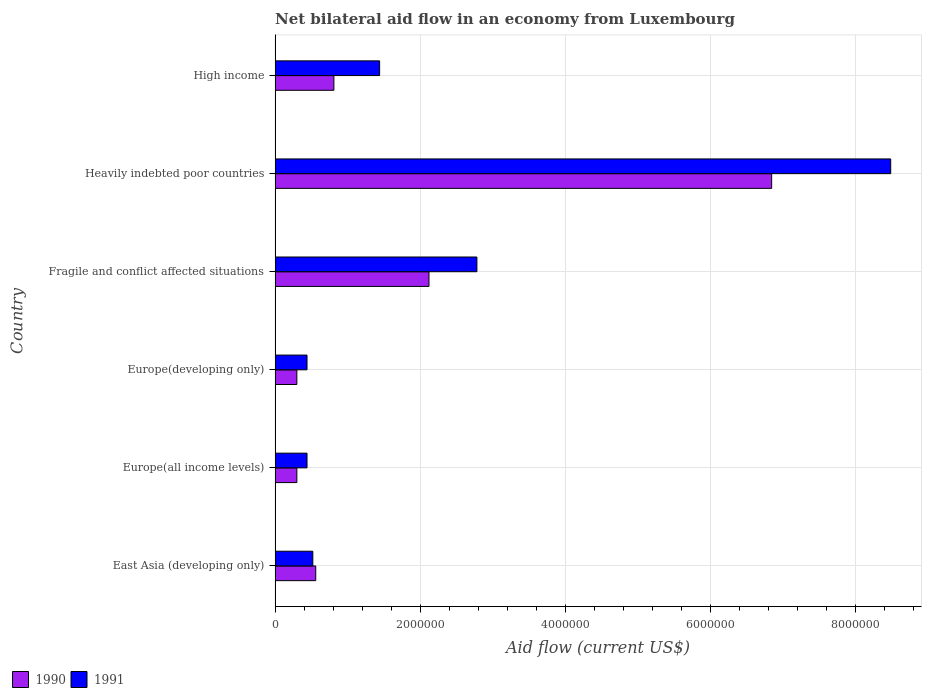How many groups of bars are there?
Give a very brief answer. 6. How many bars are there on the 2nd tick from the top?
Make the answer very short. 2. What is the label of the 3rd group of bars from the top?
Make the answer very short. Fragile and conflict affected situations. What is the net bilateral aid flow in 1990 in East Asia (developing only)?
Your response must be concise. 5.60e+05. Across all countries, what is the maximum net bilateral aid flow in 1990?
Make the answer very short. 6.84e+06. In which country was the net bilateral aid flow in 1991 maximum?
Provide a succinct answer. Heavily indebted poor countries. In which country was the net bilateral aid flow in 1991 minimum?
Your answer should be compact. Europe(all income levels). What is the total net bilateral aid flow in 1991 in the graph?
Your answer should be very brief. 1.41e+07. What is the difference between the net bilateral aid flow in 1990 in East Asia (developing only) and that in High income?
Offer a very short reply. -2.50e+05. What is the difference between the net bilateral aid flow in 1991 in Europe(all income levels) and the net bilateral aid flow in 1990 in High income?
Make the answer very short. -3.70e+05. What is the average net bilateral aid flow in 1991 per country?
Your answer should be compact. 2.35e+06. What is the difference between the net bilateral aid flow in 1990 and net bilateral aid flow in 1991 in Fragile and conflict affected situations?
Provide a succinct answer. -6.60e+05. What is the ratio of the net bilateral aid flow in 1991 in Fragile and conflict affected situations to that in High income?
Your response must be concise. 1.93. Is the difference between the net bilateral aid flow in 1990 in East Asia (developing only) and Europe(developing only) greater than the difference between the net bilateral aid flow in 1991 in East Asia (developing only) and Europe(developing only)?
Keep it short and to the point. Yes. What is the difference between the highest and the second highest net bilateral aid flow in 1990?
Provide a succinct answer. 4.72e+06. What is the difference between the highest and the lowest net bilateral aid flow in 1991?
Provide a succinct answer. 8.04e+06. In how many countries, is the net bilateral aid flow in 1990 greater than the average net bilateral aid flow in 1990 taken over all countries?
Your answer should be very brief. 2. What does the 1st bar from the top in Fragile and conflict affected situations represents?
Provide a short and direct response. 1991. How many countries are there in the graph?
Provide a succinct answer. 6. Are the values on the major ticks of X-axis written in scientific E-notation?
Keep it short and to the point. No. How many legend labels are there?
Offer a terse response. 2. How are the legend labels stacked?
Give a very brief answer. Horizontal. What is the title of the graph?
Ensure brevity in your answer.  Net bilateral aid flow in an economy from Luxembourg. What is the Aid flow (current US$) in 1990 in East Asia (developing only)?
Provide a succinct answer. 5.60e+05. What is the Aid flow (current US$) of 1991 in East Asia (developing only)?
Offer a terse response. 5.20e+05. What is the Aid flow (current US$) in 1991 in Europe(all income levels)?
Ensure brevity in your answer.  4.40e+05. What is the Aid flow (current US$) of 1991 in Europe(developing only)?
Your answer should be very brief. 4.40e+05. What is the Aid flow (current US$) of 1990 in Fragile and conflict affected situations?
Your answer should be compact. 2.12e+06. What is the Aid flow (current US$) in 1991 in Fragile and conflict affected situations?
Your answer should be compact. 2.78e+06. What is the Aid flow (current US$) in 1990 in Heavily indebted poor countries?
Make the answer very short. 6.84e+06. What is the Aid flow (current US$) in 1991 in Heavily indebted poor countries?
Your answer should be very brief. 8.48e+06. What is the Aid flow (current US$) of 1990 in High income?
Offer a terse response. 8.10e+05. What is the Aid flow (current US$) of 1991 in High income?
Your answer should be very brief. 1.44e+06. Across all countries, what is the maximum Aid flow (current US$) of 1990?
Your answer should be very brief. 6.84e+06. Across all countries, what is the maximum Aid flow (current US$) of 1991?
Ensure brevity in your answer.  8.48e+06. Across all countries, what is the minimum Aid flow (current US$) in 1990?
Offer a terse response. 3.00e+05. Across all countries, what is the minimum Aid flow (current US$) of 1991?
Your response must be concise. 4.40e+05. What is the total Aid flow (current US$) in 1990 in the graph?
Your response must be concise. 1.09e+07. What is the total Aid flow (current US$) in 1991 in the graph?
Your answer should be very brief. 1.41e+07. What is the difference between the Aid flow (current US$) of 1990 in East Asia (developing only) and that in Europe(developing only)?
Your answer should be very brief. 2.60e+05. What is the difference between the Aid flow (current US$) in 1991 in East Asia (developing only) and that in Europe(developing only)?
Provide a succinct answer. 8.00e+04. What is the difference between the Aid flow (current US$) of 1990 in East Asia (developing only) and that in Fragile and conflict affected situations?
Give a very brief answer. -1.56e+06. What is the difference between the Aid flow (current US$) in 1991 in East Asia (developing only) and that in Fragile and conflict affected situations?
Keep it short and to the point. -2.26e+06. What is the difference between the Aid flow (current US$) of 1990 in East Asia (developing only) and that in Heavily indebted poor countries?
Offer a very short reply. -6.28e+06. What is the difference between the Aid flow (current US$) of 1991 in East Asia (developing only) and that in Heavily indebted poor countries?
Ensure brevity in your answer.  -7.96e+06. What is the difference between the Aid flow (current US$) of 1990 in East Asia (developing only) and that in High income?
Make the answer very short. -2.50e+05. What is the difference between the Aid flow (current US$) in 1991 in East Asia (developing only) and that in High income?
Offer a terse response. -9.20e+05. What is the difference between the Aid flow (current US$) in 1990 in Europe(all income levels) and that in Europe(developing only)?
Your answer should be compact. 0. What is the difference between the Aid flow (current US$) of 1991 in Europe(all income levels) and that in Europe(developing only)?
Ensure brevity in your answer.  0. What is the difference between the Aid flow (current US$) of 1990 in Europe(all income levels) and that in Fragile and conflict affected situations?
Provide a succinct answer. -1.82e+06. What is the difference between the Aid flow (current US$) in 1991 in Europe(all income levels) and that in Fragile and conflict affected situations?
Make the answer very short. -2.34e+06. What is the difference between the Aid flow (current US$) in 1990 in Europe(all income levels) and that in Heavily indebted poor countries?
Make the answer very short. -6.54e+06. What is the difference between the Aid flow (current US$) in 1991 in Europe(all income levels) and that in Heavily indebted poor countries?
Your answer should be very brief. -8.04e+06. What is the difference between the Aid flow (current US$) in 1990 in Europe(all income levels) and that in High income?
Your answer should be compact. -5.10e+05. What is the difference between the Aid flow (current US$) in 1990 in Europe(developing only) and that in Fragile and conflict affected situations?
Make the answer very short. -1.82e+06. What is the difference between the Aid flow (current US$) of 1991 in Europe(developing only) and that in Fragile and conflict affected situations?
Provide a succinct answer. -2.34e+06. What is the difference between the Aid flow (current US$) of 1990 in Europe(developing only) and that in Heavily indebted poor countries?
Provide a succinct answer. -6.54e+06. What is the difference between the Aid flow (current US$) of 1991 in Europe(developing only) and that in Heavily indebted poor countries?
Your response must be concise. -8.04e+06. What is the difference between the Aid flow (current US$) in 1990 in Europe(developing only) and that in High income?
Provide a short and direct response. -5.10e+05. What is the difference between the Aid flow (current US$) in 1990 in Fragile and conflict affected situations and that in Heavily indebted poor countries?
Keep it short and to the point. -4.72e+06. What is the difference between the Aid flow (current US$) in 1991 in Fragile and conflict affected situations and that in Heavily indebted poor countries?
Offer a terse response. -5.70e+06. What is the difference between the Aid flow (current US$) in 1990 in Fragile and conflict affected situations and that in High income?
Your answer should be very brief. 1.31e+06. What is the difference between the Aid flow (current US$) of 1991 in Fragile and conflict affected situations and that in High income?
Make the answer very short. 1.34e+06. What is the difference between the Aid flow (current US$) in 1990 in Heavily indebted poor countries and that in High income?
Make the answer very short. 6.03e+06. What is the difference between the Aid flow (current US$) in 1991 in Heavily indebted poor countries and that in High income?
Provide a short and direct response. 7.04e+06. What is the difference between the Aid flow (current US$) of 1990 in East Asia (developing only) and the Aid flow (current US$) of 1991 in Europe(all income levels)?
Give a very brief answer. 1.20e+05. What is the difference between the Aid flow (current US$) of 1990 in East Asia (developing only) and the Aid flow (current US$) of 1991 in Fragile and conflict affected situations?
Offer a terse response. -2.22e+06. What is the difference between the Aid flow (current US$) in 1990 in East Asia (developing only) and the Aid flow (current US$) in 1991 in Heavily indebted poor countries?
Ensure brevity in your answer.  -7.92e+06. What is the difference between the Aid flow (current US$) in 1990 in East Asia (developing only) and the Aid flow (current US$) in 1991 in High income?
Your answer should be compact. -8.80e+05. What is the difference between the Aid flow (current US$) of 1990 in Europe(all income levels) and the Aid flow (current US$) of 1991 in Fragile and conflict affected situations?
Ensure brevity in your answer.  -2.48e+06. What is the difference between the Aid flow (current US$) in 1990 in Europe(all income levels) and the Aid flow (current US$) in 1991 in Heavily indebted poor countries?
Your answer should be very brief. -8.18e+06. What is the difference between the Aid flow (current US$) in 1990 in Europe(all income levels) and the Aid flow (current US$) in 1991 in High income?
Offer a very short reply. -1.14e+06. What is the difference between the Aid flow (current US$) in 1990 in Europe(developing only) and the Aid flow (current US$) in 1991 in Fragile and conflict affected situations?
Make the answer very short. -2.48e+06. What is the difference between the Aid flow (current US$) of 1990 in Europe(developing only) and the Aid flow (current US$) of 1991 in Heavily indebted poor countries?
Your answer should be compact. -8.18e+06. What is the difference between the Aid flow (current US$) in 1990 in Europe(developing only) and the Aid flow (current US$) in 1991 in High income?
Offer a terse response. -1.14e+06. What is the difference between the Aid flow (current US$) in 1990 in Fragile and conflict affected situations and the Aid flow (current US$) in 1991 in Heavily indebted poor countries?
Offer a terse response. -6.36e+06. What is the difference between the Aid flow (current US$) in 1990 in Fragile and conflict affected situations and the Aid flow (current US$) in 1991 in High income?
Offer a terse response. 6.80e+05. What is the difference between the Aid flow (current US$) in 1990 in Heavily indebted poor countries and the Aid flow (current US$) in 1991 in High income?
Ensure brevity in your answer.  5.40e+06. What is the average Aid flow (current US$) in 1990 per country?
Make the answer very short. 1.82e+06. What is the average Aid flow (current US$) in 1991 per country?
Make the answer very short. 2.35e+06. What is the difference between the Aid flow (current US$) in 1990 and Aid flow (current US$) in 1991 in East Asia (developing only)?
Your response must be concise. 4.00e+04. What is the difference between the Aid flow (current US$) of 1990 and Aid flow (current US$) of 1991 in Europe(developing only)?
Keep it short and to the point. -1.40e+05. What is the difference between the Aid flow (current US$) of 1990 and Aid flow (current US$) of 1991 in Fragile and conflict affected situations?
Keep it short and to the point. -6.60e+05. What is the difference between the Aid flow (current US$) of 1990 and Aid flow (current US$) of 1991 in Heavily indebted poor countries?
Give a very brief answer. -1.64e+06. What is the difference between the Aid flow (current US$) of 1990 and Aid flow (current US$) of 1991 in High income?
Provide a succinct answer. -6.30e+05. What is the ratio of the Aid flow (current US$) of 1990 in East Asia (developing only) to that in Europe(all income levels)?
Provide a succinct answer. 1.87. What is the ratio of the Aid flow (current US$) in 1991 in East Asia (developing only) to that in Europe(all income levels)?
Your response must be concise. 1.18. What is the ratio of the Aid flow (current US$) of 1990 in East Asia (developing only) to that in Europe(developing only)?
Offer a terse response. 1.87. What is the ratio of the Aid flow (current US$) in 1991 in East Asia (developing only) to that in Europe(developing only)?
Your answer should be compact. 1.18. What is the ratio of the Aid flow (current US$) in 1990 in East Asia (developing only) to that in Fragile and conflict affected situations?
Your response must be concise. 0.26. What is the ratio of the Aid flow (current US$) in 1991 in East Asia (developing only) to that in Fragile and conflict affected situations?
Your answer should be very brief. 0.19. What is the ratio of the Aid flow (current US$) of 1990 in East Asia (developing only) to that in Heavily indebted poor countries?
Offer a very short reply. 0.08. What is the ratio of the Aid flow (current US$) in 1991 in East Asia (developing only) to that in Heavily indebted poor countries?
Keep it short and to the point. 0.06. What is the ratio of the Aid flow (current US$) in 1990 in East Asia (developing only) to that in High income?
Offer a terse response. 0.69. What is the ratio of the Aid flow (current US$) of 1991 in East Asia (developing only) to that in High income?
Your answer should be very brief. 0.36. What is the ratio of the Aid flow (current US$) in 1990 in Europe(all income levels) to that in Europe(developing only)?
Give a very brief answer. 1. What is the ratio of the Aid flow (current US$) in 1991 in Europe(all income levels) to that in Europe(developing only)?
Provide a succinct answer. 1. What is the ratio of the Aid flow (current US$) of 1990 in Europe(all income levels) to that in Fragile and conflict affected situations?
Your response must be concise. 0.14. What is the ratio of the Aid flow (current US$) of 1991 in Europe(all income levels) to that in Fragile and conflict affected situations?
Your answer should be compact. 0.16. What is the ratio of the Aid flow (current US$) in 1990 in Europe(all income levels) to that in Heavily indebted poor countries?
Your answer should be very brief. 0.04. What is the ratio of the Aid flow (current US$) of 1991 in Europe(all income levels) to that in Heavily indebted poor countries?
Your answer should be compact. 0.05. What is the ratio of the Aid flow (current US$) of 1990 in Europe(all income levels) to that in High income?
Offer a terse response. 0.37. What is the ratio of the Aid flow (current US$) in 1991 in Europe(all income levels) to that in High income?
Offer a very short reply. 0.31. What is the ratio of the Aid flow (current US$) in 1990 in Europe(developing only) to that in Fragile and conflict affected situations?
Your answer should be compact. 0.14. What is the ratio of the Aid flow (current US$) of 1991 in Europe(developing only) to that in Fragile and conflict affected situations?
Offer a terse response. 0.16. What is the ratio of the Aid flow (current US$) of 1990 in Europe(developing only) to that in Heavily indebted poor countries?
Provide a short and direct response. 0.04. What is the ratio of the Aid flow (current US$) in 1991 in Europe(developing only) to that in Heavily indebted poor countries?
Keep it short and to the point. 0.05. What is the ratio of the Aid flow (current US$) of 1990 in Europe(developing only) to that in High income?
Your answer should be compact. 0.37. What is the ratio of the Aid flow (current US$) of 1991 in Europe(developing only) to that in High income?
Provide a succinct answer. 0.31. What is the ratio of the Aid flow (current US$) of 1990 in Fragile and conflict affected situations to that in Heavily indebted poor countries?
Make the answer very short. 0.31. What is the ratio of the Aid flow (current US$) of 1991 in Fragile and conflict affected situations to that in Heavily indebted poor countries?
Offer a very short reply. 0.33. What is the ratio of the Aid flow (current US$) of 1990 in Fragile and conflict affected situations to that in High income?
Make the answer very short. 2.62. What is the ratio of the Aid flow (current US$) in 1991 in Fragile and conflict affected situations to that in High income?
Offer a very short reply. 1.93. What is the ratio of the Aid flow (current US$) of 1990 in Heavily indebted poor countries to that in High income?
Your response must be concise. 8.44. What is the ratio of the Aid flow (current US$) in 1991 in Heavily indebted poor countries to that in High income?
Your answer should be very brief. 5.89. What is the difference between the highest and the second highest Aid flow (current US$) in 1990?
Give a very brief answer. 4.72e+06. What is the difference between the highest and the second highest Aid flow (current US$) in 1991?
Offer a very short reply. 5.70e+06. What is the difference between the highest and the lowest Aid flow (current US$) of 1990?
Give a very brief answer. 6.54e+06. What is the difference between the highest and the lowest Aid flow (current US$) in 1991?
Provide a succinct answer. 8.04e+06. 